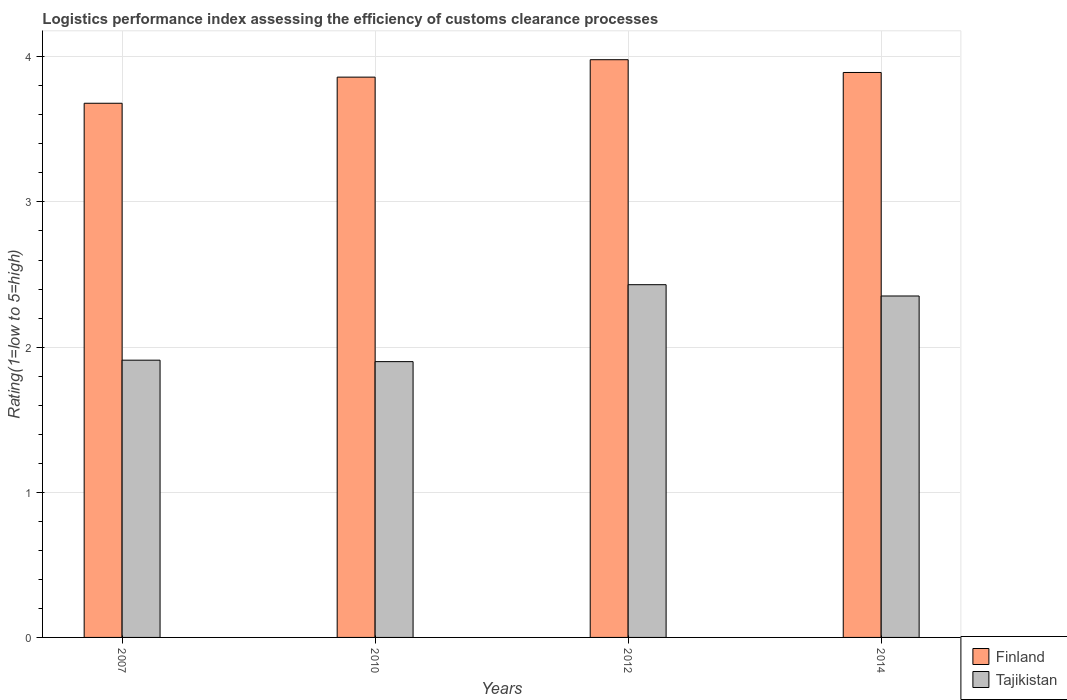Are the number of bars per tick equal to the number of legend labels?
Provide a succinct answer. Yes. How many bars are there on the 3rd tick from the right?
Give a very brief answer. 2. What is the Logistic performance index in Tajikistan in 2007?
Provide a short and direct response. 1.91. Across all years, what is the maximum Logistic performance index in Finland?
Offer a very short reply. 3.98. In which year was the Logistic performance index in Finland maximum?
Offer a very short reply. 2012. What is the total Logistic performance index in Tajikistan in the graph?
Your answer should be compact. 8.59. What is the difference between the Logistic performance index in Finland in 2010 and that in 2014?
Offer a very short reply. -0.03. What is the difference between the Logistic performance index in Finland in 2007 and the Logistic performance index in Tajikistan in 2014?
Provide a succinct answer. 1.33. What is the average Logistic performance index in Tajikistan per year?
Offer a terse response. 2.15. In the year 2012, what is the difference between the Logistic performance index in Finland and Logistic performance index in Tajikistan?
Offer a very short reply. 1.55. In how many years, is the Logistic performance index in Tajikistan greater than 1?
Provide a succinct answer. 4. What is the ratio of the Logistic performance index in Finland in 2012 to that in 2014?
Ensure brevity in your answer.  1.02. Is the difference between the Logistic performance index in Finland in 2007 and 2010 greater than the difference between the Logistic performance index in Tajikistan in 2007 and 2010?
Make the answer very short. No. What is the difference between the highest and the second highest Logistic performance index in Finland?
Your answer should be very brief. 0.09. What is the difference between the highest and the lowest Logistic performance index in Finland?
Give a very brief answer. 0.3. In how many years, is the Logistic performance index in Finland greater than the average Logistic performance index in Finland taken over all years?
Keep it short and to the point. 3. Is the sum of the Logistic performance index in Finland in 2007 and 2014 greater than the maximum Logistic performance index in Tajikistan across all years?
Provide a succinct answer. Yes. What does the 2nd bar from the left in 2010 represents?
Your answer should be compact. Tajikistan. What does the 1st bar from the right in 2014 represents?
Ensure brevity in your answer.  Tajikistan. How many bars are there?
Ensure brevity in your answer.  8. Does the graph contain any zero values?
Your answer should be very brief. No. Does the graph contain grids?
Make the answer very short. Yes. How are the legend labels stacked?
Make the answer very short. Vertical. What is the title of the graph?
Give a very brief answer. Logistics performance index assessing the efficiency of customs clearance processes. What is the label or title of the X-axis?
Your response must be concise. Years. What is the label or title of the Y-axis?
Your answer should be compact. Rating(1=low to 5=high). What is the Rating(1=low to 5=high) in Finland in 2007?
Your response must be concise. 3.68. What is the Rating(1=low to 5=high) in Tajikistan in 2007?
Offer a very short reply. 1.91. What is the Rating(1=low to 5=high) of Finland in 2010?
Keep it short and to the point. 3.86. What is the Rating(1=low to 5=high) in Finland in 2012?
Make the answer very short. 3.98. What is the Rating(1=low to 5=high) in Tajikistan in 2012?
Offer a very short reply. 2.43. What is the Rating(1=low to 5=high) of Finland in 2014?
Provide a short and direct response. 3.89. What is the Rating(1=low to 5=high) in Tajikistan in 2014?
Provide a short and direct response. 2.35. Across all years, what is the maximum Rating(1=low to 5=high) in Finland?
Keep it short and to the point. 3.98. Across all years, what is the maximum Rating(1=low to 5=high) of Tajikistan?
Ensure brevity in your answer.  2.43. Across all years, what is the minimum Rating(1=low to 5=high) of Finland?
Make the answer very short. 3.68. Across all years, what is the minimum Rating(1=low to 5=high) of Tajikistan?
Provide a succinct answer. 1.9. What is the total Rating(1=low to 5=high) of Finland in the graph?
Give a very brief answer. 15.41. What is the total Rating(1=low to 5=high) in Tajikistan in the graph?
Offer a terse response. 8.59. What is the difference between the Rating(1=low to 5=high) in Finland in 2007 and that in 2010?
Give a very brief answer. -0.18. What is the difference between the Rating(1=low to 5=high) in Tajikistan in 2007 and that in 2012?
Your answer should be compact. -0.52. What is the difference between the Rating(1=low to 5=high) in Finland in 2007 and that in 2014?
Ensure brevity in your answer.  -0.21. What is the difference between the Rating(1=low to 5=high) in Tajikistan in 2007 and that in 2014?
Give a very brief answer. -0.44. What is the difference between the Rating(1=low to 5=high) of Finland in 2010 and that in 2012?
Give a very brief answer. -0.12. What is the difference between the Rating(1=low to 5=high) in Tajikistan in 2010 and that in 2012?
Provide a succinct answer. -0.53. What is the difference between the Rating(1=low to 5=high) of Finland in 2010 and that in 2014?
Your answer should be compact. -0.03. What is the difference between the Rating(1=low to 5=high) in Tajikistan in 2010 and that in 2014?
Provide a succinct answer. -0.45. What is the difference between the Rating(1=low to 5=high) in Finland in 2012 and that in 2014?
Provide a short and direct response. 0.09. What is the difference between the Rating(1=low to 5=high) of Tajikistan in 2012 and that in 2014?
Make the answer very short. 0.08. What is the difference between the Rating(1=low to 5=high) in Finland in 2007 and the Rating(1=low to 5=high) in Tajikistan in 2010?
Provide a short and direct response. 1.78. What is the difference between the Rating(1=low to 5=high) in Finland in 2007 and the Rating(1=low to 5=high) in Tajikistan in 2012?
Ensure brevity in your answer.  1.25. What is the difference between the Rating(1=low to 5=high) of Finland in 2007 and the Rating(1=low to 5=high) of Tajikistan in 2014?
Ensure brevity in your answer.  1.33. What is the difference between the Rating(1=low to 5=high) in Finland in 2010 and the Rating(1=low to 5=high) in Tajikistan in 2012?
Make the answer very short. 1.43. What is the difference between the Rating(1=low to 5=high) in Finland in 2010 and the Rating(1=low to 5=high) in Tajikistan in 2014?
Provide a succinct answer. 1.51. What is the difference between the Rating(1=low to 5=high) in Finland in 2012 and the Rating(1=low to 5=high) in Tajikistan in 2014?
Make the answer very short. 1.63. What is the average Rating(1=low to 5=high) of Finland per year?
Give a very brief answer. 3.85. What is the average Rating(1=low to 5=high) in Tajikistan per year?
Your answer should be very brief. 2.15. In the year 2007, what is the difference between the Rating(1=low to 5=high) in Finland and Rating(1=low to 5=high) in Tajikistan?
Make the answer very short. 1.77. In the year 2010, what is the difference between the Rating(1=low to 5=high) in Finland and Rating(1=low to 5=high) in Tajikistan?
Your answer should be compact. 1.96. In the year 2012, what is the difference between the Rating(1=low to 5=high) in Finland and Rating(1=low to 5=high) in Tajikistan?
Offer a terse response. 1.55. In the year 2014, what is the difference between the Rating(1=low to 5=high) in Finland and Rating(1=low to 5=high) in Tajikistan?
Keep it short and to the point. 1.54. What is the ratio of the Rating(1=low to 5=high) of Finland in 2007 to that in 2010?
Provide a succinct answer. 0.95. What is the ratio of the Rating(1=low to 5=high) in Tajikistan in 2007 to that in 2010?
Provide a short and direct response. 1.01. What is the ratio of the Rating(1=low to 5=high) in Finland in 2007 to that in 2012?
Offer a terse response. 0.92. What is the ratio of the Rating(1=low to 5=high) of Tajikistan in 2007 to that in 2012?
Ensure brevity in your answer.  0.79. What is the ratio of the Rating(1=low to 5=high) of Finland in 2007 to that in 2014?
Offer a terse response. 0.95. What is the ratio of the Rating(1=low to 5=high) in Tajikistan in 2007 to that in 2014?
Make the answer very short. 0.81. What is the ratio of the Rating(1=low to 5=high) in Finland in 2010 to that in 2012?
Provide a succinct answer. 0.97. What is the ratio of the Rating(1=low to 5=high) of Tajikistan in 2010 to that in 2012?
Make the answer very short. 0.78. What is the ratio of the Rating(1=low to 5=high) of Tajikistan in 2010 to that in 2014?
Make the answer very short. 0.81. What is the ratio of the Rating(1=low to 5=high) of Finland in 2012 to that in 2014?
Offer a terse response. 1.02. What is the ratio of the Rating(1=low to 5=high) in Tajikistan in 2012 to that in 2014?
Give a very brief answer. 1.03. What is the difference between the highest and the second highest Rating(1=low to 5=high) of Finland?
Offer a terse response. 0.09. What is the difference between the highest and the second highest Rating(1=low to 5=high) in Tajikistan?
Your response must be concise. 0.08. What is the difference between the highest and the lowest Rating(1=low to 5=high) of Tajikistan?
Provide a short and direct response. 0.53. 